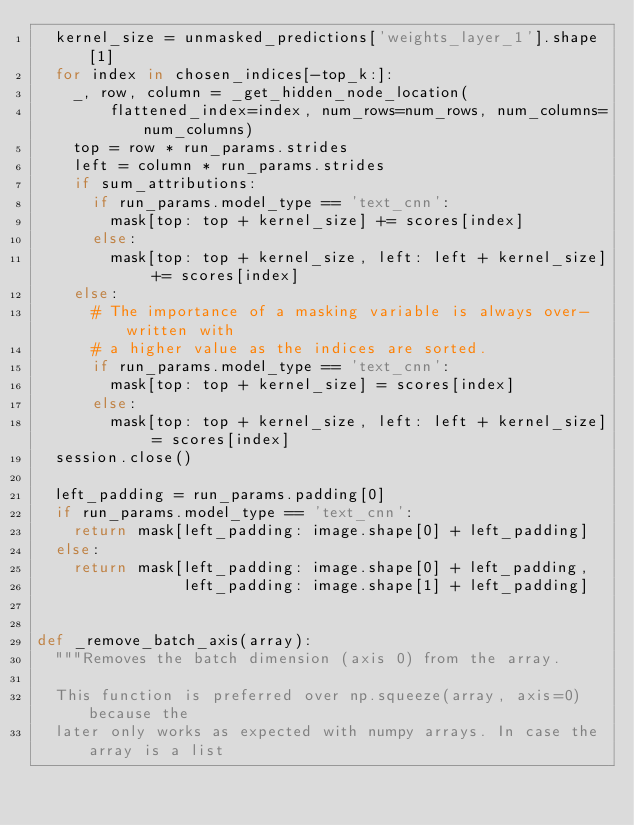Convert code to text. <code><loc_0><loc_0><loc_500><loc_500><_Python_>  kernel_size = unmasked_predictions['weights_layer_1'].shape[1]
  for index in chosen_indices[-top_k:]:
    _, row, column = _get_hidden_node_location(
        flattened_index=index, num_rows=num_rows, num_columns=num_columns)
    top = row * run_params.strides
    left = column * run_params.strides
    if sum_attributions:
      if run_params.model_type == 'text_cnn':
        mask[top: top + kernel_size] += scores[index]
      else:
        mask[top: top + kernel_size, left: left + kernel_size] += scores[index]
    else:
      # The importance of a masking variable is always over-written with
      # a higher value as the indices are sorted.
      if run_params.model_type == 'text_cnn':
        mask[top: top + kernel_size] = scores[index]
      else:
        mask[top: top + kernel_size, left: left + kernel_size] = scores[index]
  session.close()

  left_padding = run_params.padding[0]
  if run_params.model_type == 'text_cnn':
    return mask[left_padding: image.shape[0] + left_padding]
  else:
    return mask[left_padding: image.shape[0] + left_padding,
                left_padding: image.shape[1] + left_padding]


def _remove_batch_axis(array):
  """Removes the batch dimension (axis 0) from the array.

  This function is preferred over np.squeeze(array, axis=0) because the
  later only works as expected with numpy arrays. In case the array is a list</code> 